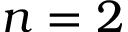Convert formula to latex. <formula><loc_0><loc_0><loc_500><loc_500>n = 2</formula> 